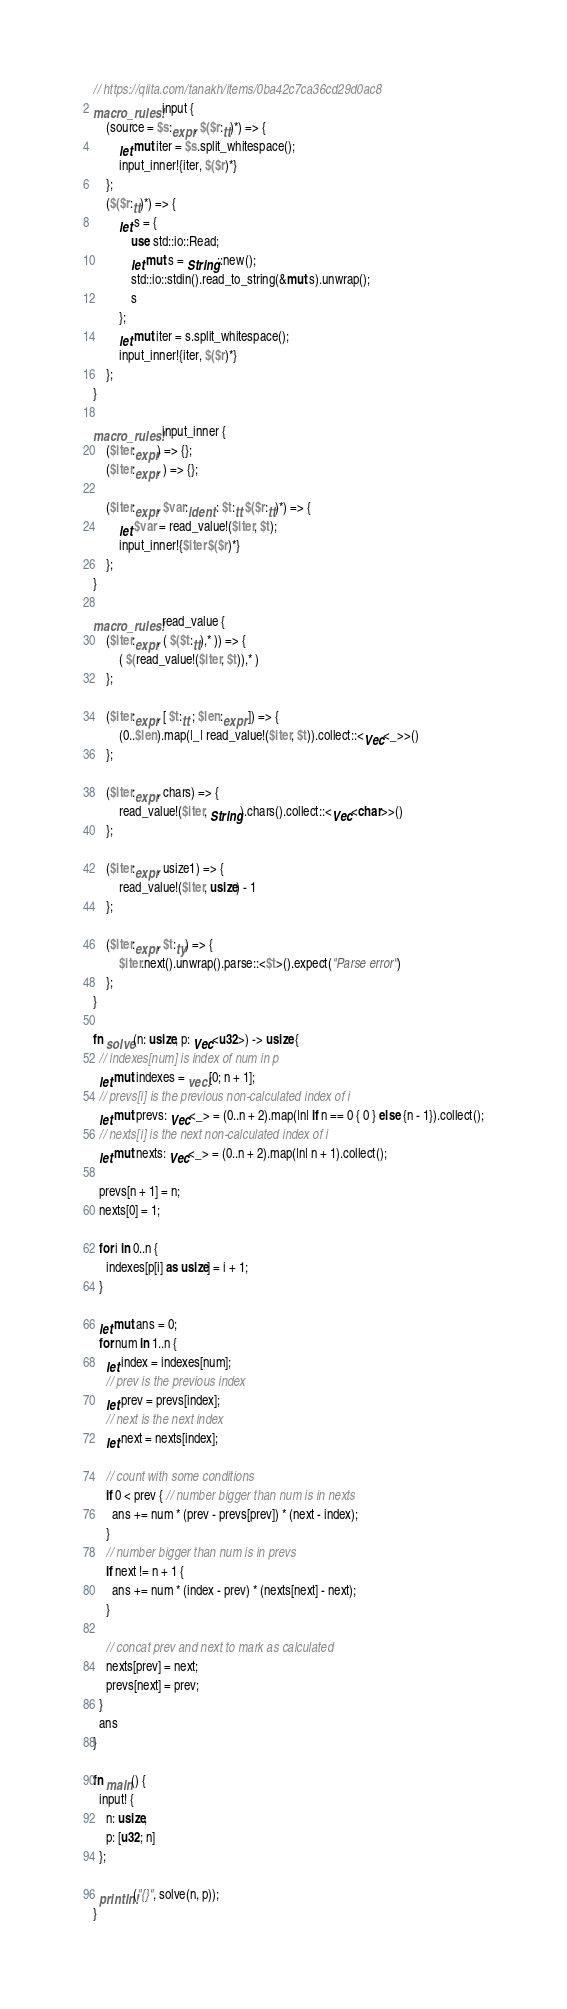Convert code to text. <code><loc_0><loc_0><loc_500><loc_500><_Rust_>// https://qiita.com/tanakh/items/0ba42c7ca36cd29d0ac8
macro_rules! input {
    (source = $s:expr, $($r:tt)*) => {
        let mut iter = $s.split_whitespace();
        input_inner!{iter, $($r)*}
    };
    ($($r:tt)*) => {
        let s = {
            use std::io::Read;
            let mut s = String::new();
            std::io::stdin().read_to_string(&mut s).unwrap();
            s
        };
        let mut iter = s.split_whitespace();
        input_inner!{iter, $($r)*}
    };
}

macro_rules! input_inner {
    ($iter:expr) => {};
    ($iter:expr, ) => {};

    ($iter:expr, $var:ident : $t:tt $($r:tt)*) => {
        let $var = read_value!($iter, $t);
        input_inner!{$iter $($r)*}
    };
}

macro_rules! read_value {
    ($iter:expr, ( $($t:tt),* )) => {
        ( $(read_value!($iter, $t)),* )
    };

    ($iter:expr, [ $t:tt ; $len:expr ]) => {
        (0..$len).map(|_| read_value!($iter, $t)).collect::<Vec<_>>()
    };

    ($iter:expr, chars) => {
        read_value!($iter, String).chars().collect::<Vec<char>>()
    };

    ($iter:expr, usize1) => {
        read_value!($iter, usize) - 1
    };

    ($iter:expr, $t:ty) => {
        $iter.next().unwrap().parse::<$t>().expect("Parse error")
    };
}

fn solve(n: usize, p: Vec<u32>) -> usize {
  // indexes[num] is index of num in p
  let mut indexes = vec![0; n + 1];
  // prevs[i] is the previous non-calculated index of i
  let mut prevs: Vec<_> = (0..n + 2).map(|n| if n == 0 { 0 } else {n - 1}).collect();
  // nexts[i] is the next non-calculated index of i
  let mut nexts: Vec<_> = (0..n + 2).map(|n| n + 1).collect();

  prevs[n + 1] = n;
  nexts[0] = 1;

  for i in 0..n {
    indexes[p[i] as usize] = i + 1;
  }

  let mut ans = 0;
  for num in 1..n {
    let index = indexes[num];
    // prev is the previous index
    let prev = prevs[index];
    // next is the next index
    let next = nexts[index];

    // count with some conditions
    if 0 < prev { // number bigger than num is in nexts
      ans += num * (prev - prevs[prev]) * (next - index);
    }
    // number bigger than num is in prevs
    if next != n + 1 {
      ans += num * (index - prev) * (nexts[next] - next);
    }

    // concat prev and next to mark as calculated
    nexts[prev] = next;
    prevs[next] = prev;
  }
  ans
}

fn main() {
  input! {
    n: usize,
    p: [u32; n]
  };

  println!("{}", solve(n, p));
}
</code> 